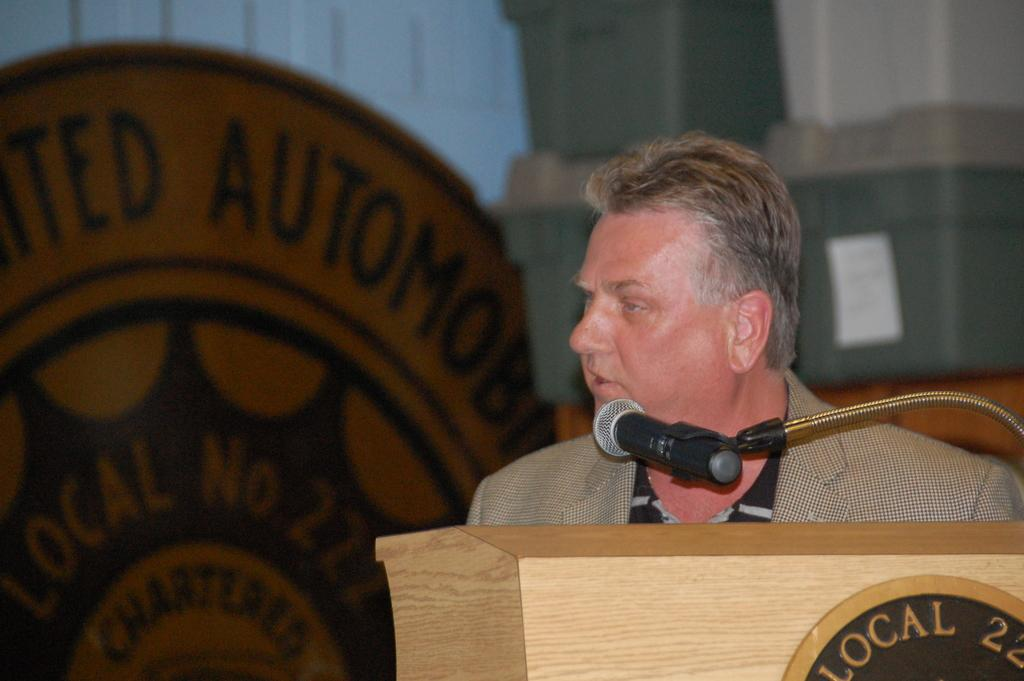Who or what is in the image? There is a person in the image. What is in front of the person? There is a podium and a microphone in front of the person. What is behind the person? There is a wall and an object with text on it behind the person. What type of ship can be seen sailing behind the person in the image? There is no ship present in the image; it only features a person, a podium, a microphone, a wall, and an object with text. 